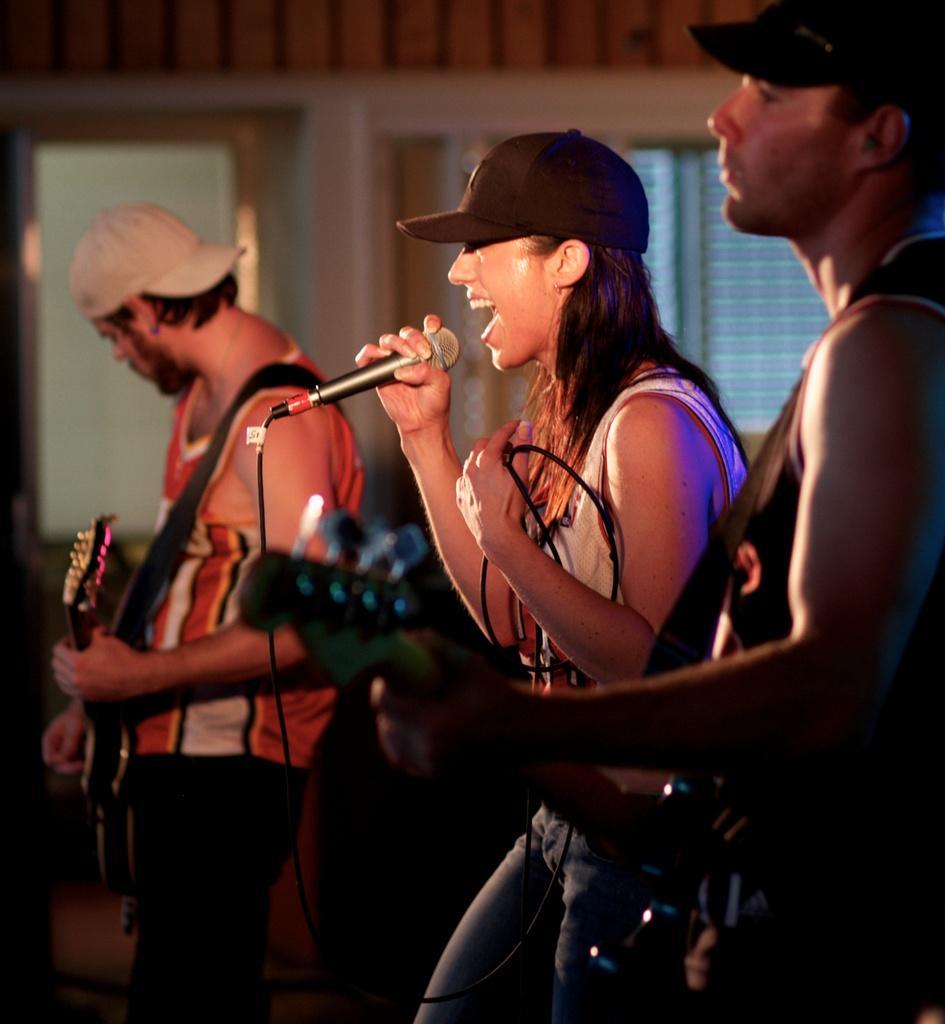Could you give a brief overview of what you see in this image? In this image, 3 peoples are there. Right side man and left side man is playing a musical instrument. Middle, women is wearing a cap ,she hold a mic and she is singing. Right side person and left side person also wear a cap on his head. We can see wire here. Background, we can see a glass windows and wall. 